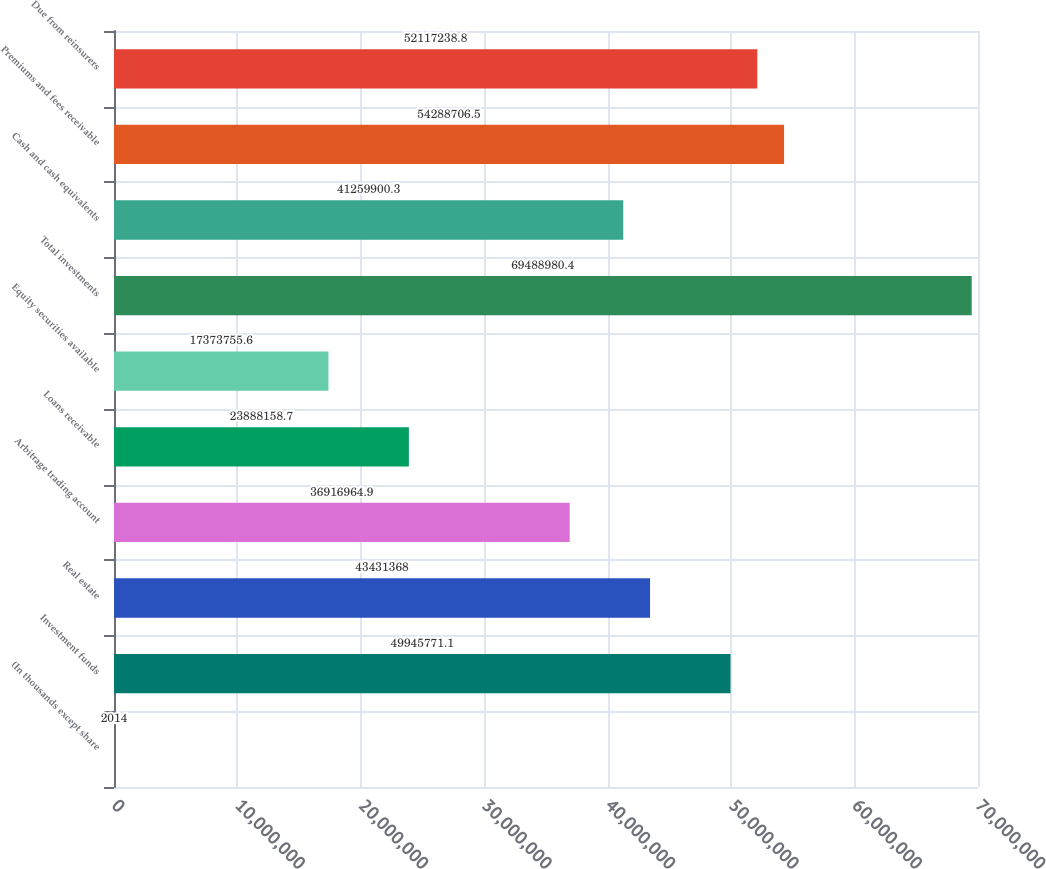Convert chart. <chart><loc_0><loc_0><loc_500><loc_500><bar_chart><fcel>(In thousands except share<fcel>Investment funds<fcel>Real estate<fcel>Arbitrage trading account<fcel>Loans receivable<fcel>Equity securities available<fcel>Total investments<fcel>Cash and cash equivalents<fcel>Premiums and fees receivable<fcel>Due from reinsurers<nl><fcel>2014<fcel>4.99458e+07<fcel>4.34314e+07<fcel>3.6917e+07<fcel>2.38882e+07<fcel>1.73738e+07<fcel>6.9489e+07<fcel>4.12599e+07<fcel>5.42887e+07<fcel>5.21172e+07<nl></chart> 